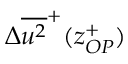Convert formula to latex. <formula><loc_0><loc_0><loc_500><loc_500>{ \Delta } { { \overline { { { u ^ { 2 } } } } } ^ { + } } ( z _ { O P } ^ { + } )</formula> 